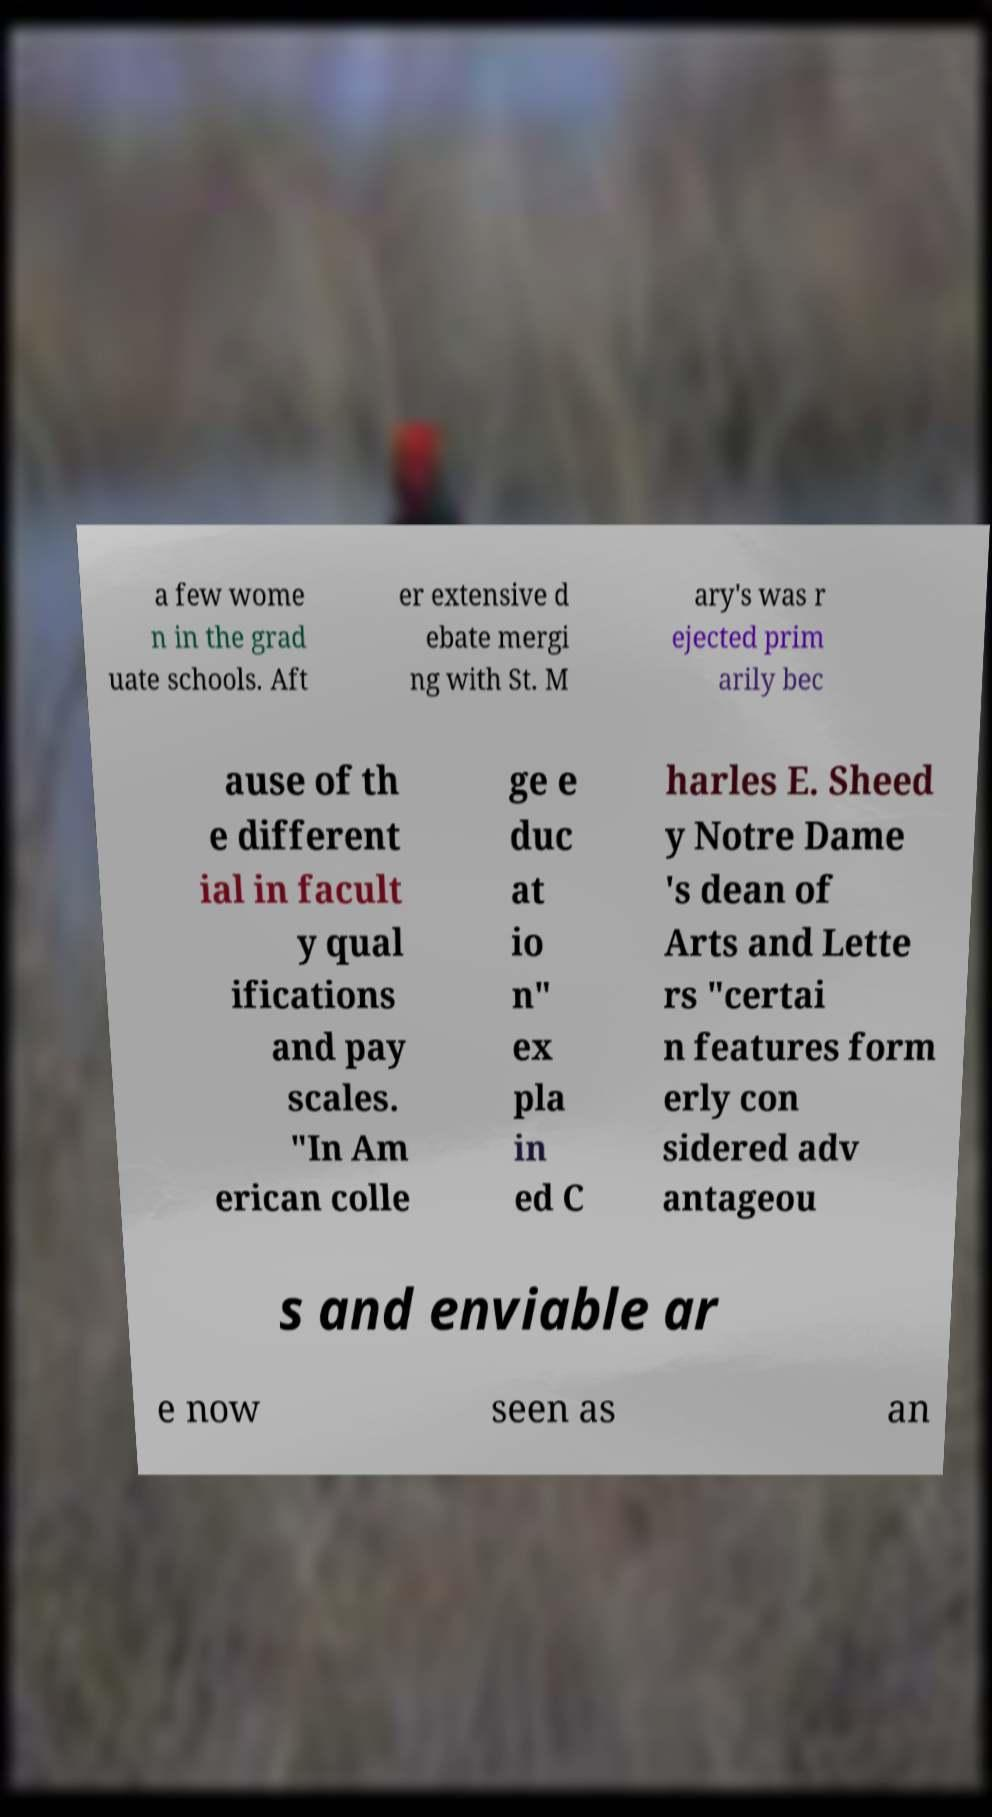For documentation purposes, I need the text within this image transcribed. Could you provide that? a few wome n in the grad uate schools. Aft er extensive d ebate mergi ng with St. M ary's was r ejected prim arily bec ause of th e different ial in facult y qual ifications and pay scales. "In Am erican colle ge e duc at io n" ex pla in ed C harles E. Sheed y Notre Dame 's dean of Arts and Lette rs "certai n features form erly con sidered adv antageou s and enviable ar e now seen as an 